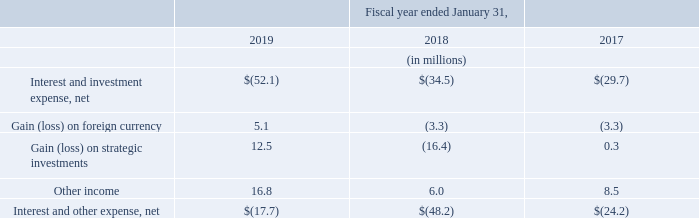Interest and Other Expense, Net
The following table sets forth the components of interest and other expense, net:
Interest and other expense, net, positively changed by $30.5 million during fiscal 2019, as compared to fiscal 2018, primarily driven by curtailment gains on our pension plans, mark-to-market gains on certain of our privately-held strategic investments, realized gains on sales of strategic investments, offset by an increase in interest expense resulting from our term loan entered into on December 17, 2018 in aggregate principal amount of $500 million and mark-to-market losses on marketable securities.
Interest and other expense, net, increased $24.0 million during fiscal 2018, as compared to fiscal 2017, primarily related to increases in impairment losses on certain of our privately-held strategic investments and interest expense resulting from our June 2017 issuance of $500.0 million aggregate principal amount of 3.5% notes due June 15, 2027.
Interest expense and investment income fluctuates based on average cash, marketable securities and debt balances, average maturities and interest rates.
Gains and losses on foreign currency are primarily due to the impact of re-measuring foreign currency transactions and net monetary assets into the functional currency of the corresponding entity. The amount of the gain or loss on foreign currency is driven by the volume of foreign currency transactions and the foreign currency exchange rates for the year
Why was there less interest and other expense in 2019 compared to 2018? Primarily driven by curtailment gains on our pension plans, mark-to-market gains on certain of our privately-held strategic investments, realized gains on sales of strategic investments, offset by an increase in interest expense resulting from our term loan entered into on december 17, 2018 in aggregate principal amount of $500 million and mark-to-market losses on marketable securities. What is average "other income" for the 3 year period from 2017 to 2019?
Answer scale should be: million. (16.8 + 6.0 + 8.5) / 3 
Answer: 10.43. Why was there a loss in strategic investments in 2018 compared to 2017? Impairment losses. How much did net interest and investment expense increase over fiscal year ending January 31, 2019?
Answer scale should be: percent. (52.1-34.5)/34.5 
Answer: 51.01. What determines the amount of gain or loss on the foreign currency? Volume of foreign currency transactions and the foreign currency exchange rates for the year. What is the total net interest and other expenses for all 3 years?
Answer scale should be: million. 17.7+48.2+24.2
Answer: 90.1. 